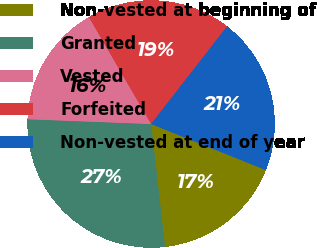Convert chart. <chart><loc_0><loc_0><loc_500><loc_500><pie_chart><fcel>Non-vested at beginning of<fcel>Granted<fcel>Vested<fcel>Forfeited<fcel>Non-vested at end of year<nl><fcel>17.13%<fcel>27.41%<fcel>15.99%<fcel>18.92%<fcel>20.55%<nl></chart> 